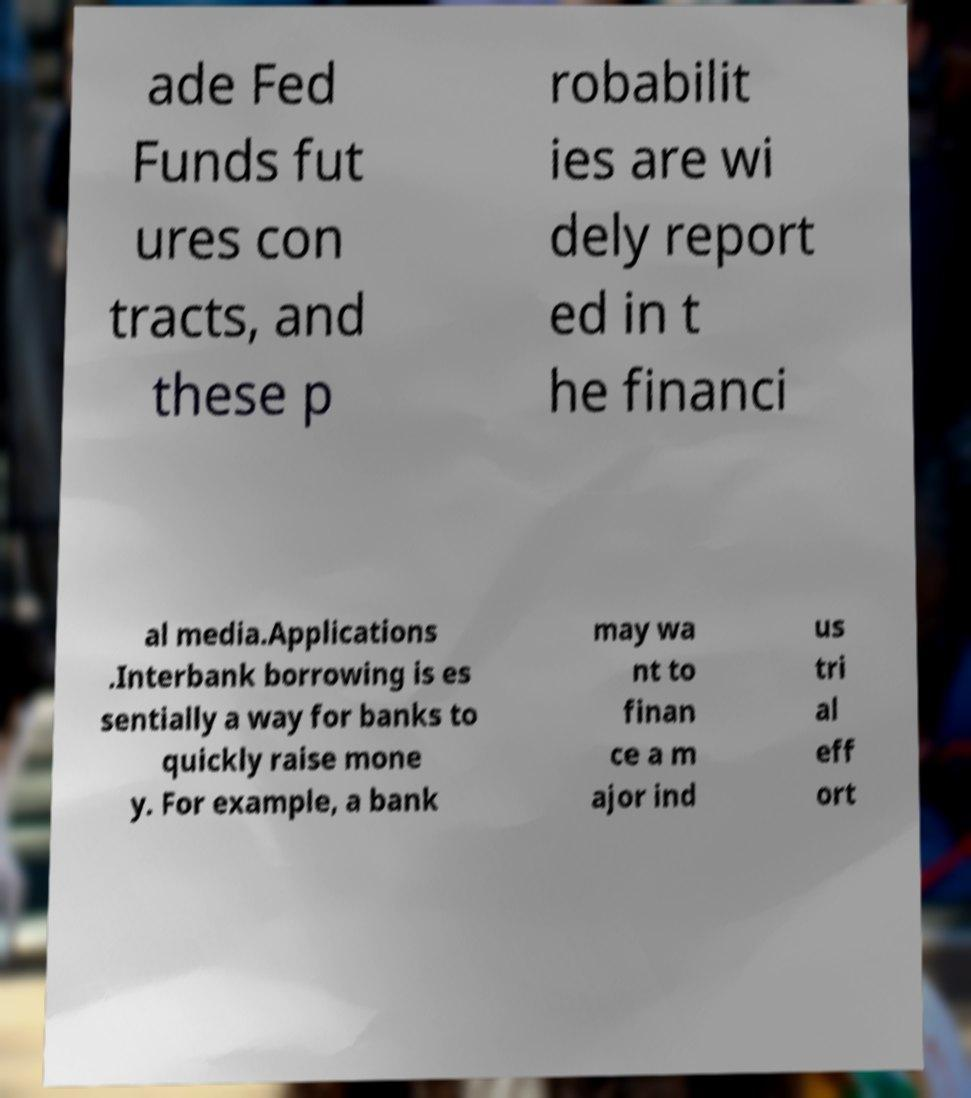For documentation purposes, I need the text within this image transcribed. Could you provide that? ade Fed Funds fut ures con tracts, and these p robabilit ies are wi dely report ed in t he financi al media.Applications .Interbank borrowing is es sentially a way for banks to quickly raise mone y. For example, a bank may wa nt to finan ce a m ajor ind us tri al eff ort 